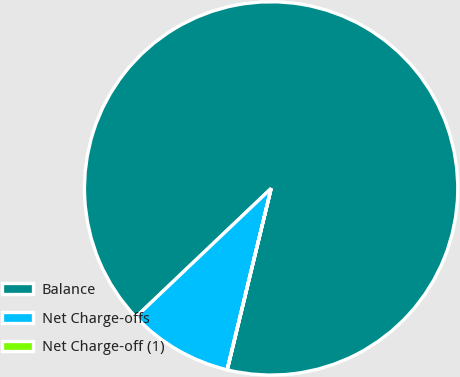<chart> <loc_0><loc_0><loc_500><loc_500><pie_chart><fcel>Balance<fcel>Net Charge-offs<fcel>Net Charge-off (1)<nl><fcel>90.87%<fcel>9.11%<fcel>0.02%<nl></chart> 